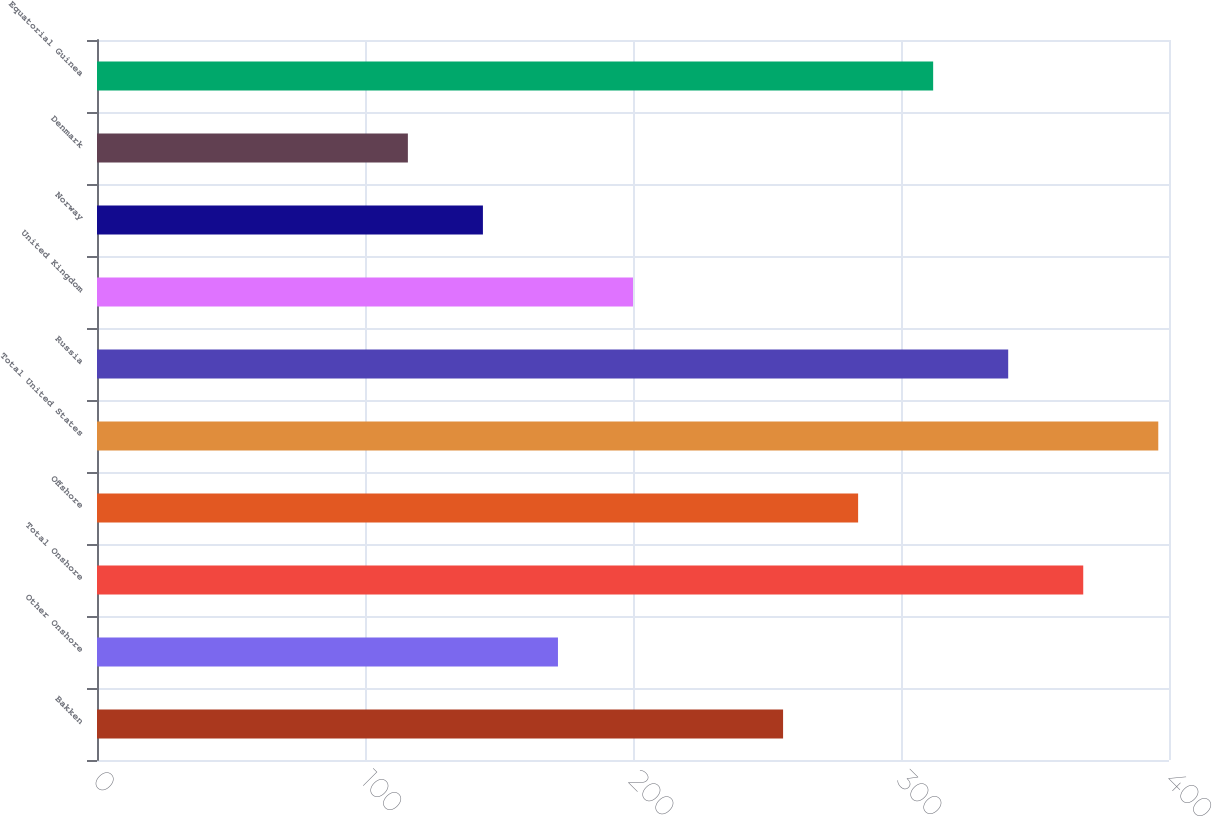Convert chart. <chart><loc_0><loc_0><loc_500><loc_500><bar_chart><fcel>Bakken<fcel>Other Onshore<fcel>Total Onshore<fcel>Offshore<fcel>Total United States<fcel>Russia<fcel>United Kingdom<fcel>Norway<fcel>Denmark<fcel>Equatorial Guinea<nl><fcel>256<fcel>172<fcel>368<fcel>284<fcel>396<fcel>340<fcel>200<fcel>144<fcel>116<fcel>312<nl></chart> 